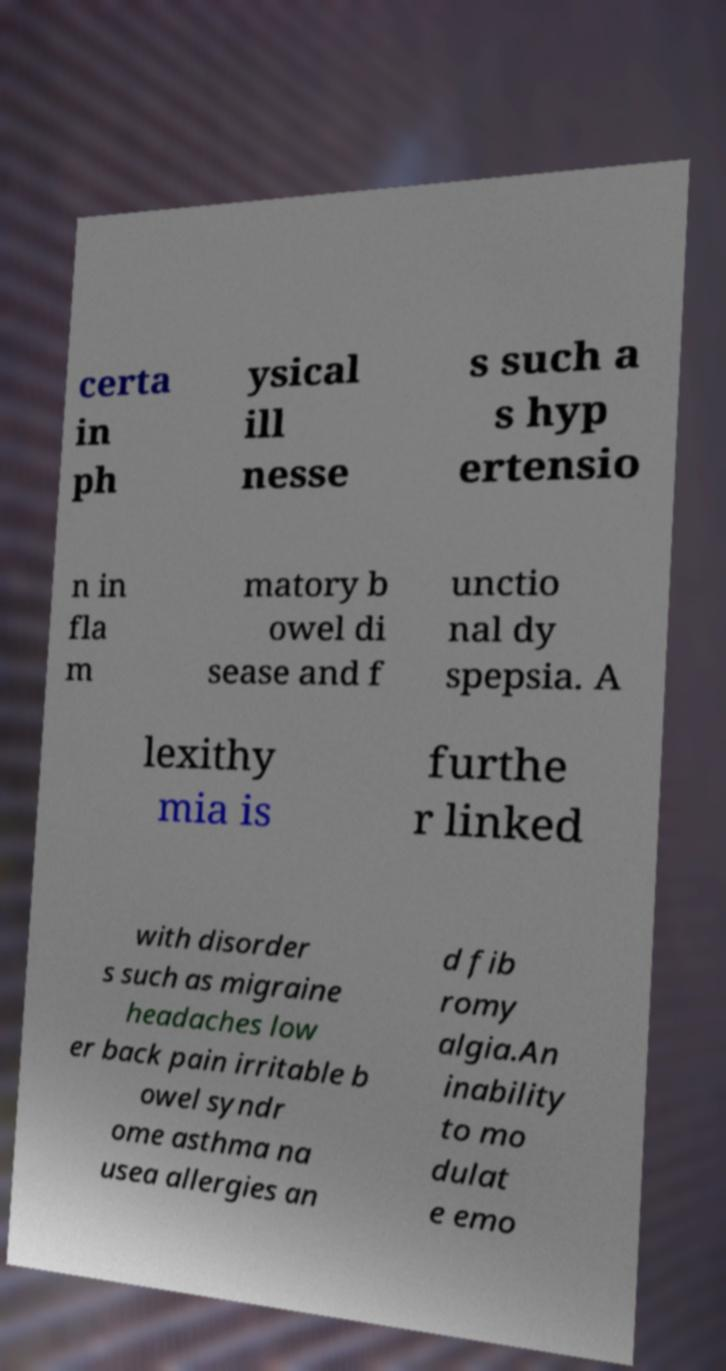I need the written content from this picture converted into text. Can you do that? certa in ph ysical ill nesse s such a s hyp ertensio n in fla m matory b owel di sease and f unctio nal dy spepsia. A lexithy mia is furthe r linked with disorder s such as migraine headaches low er back pain irritable b owel syndr ome asthma na usea allergies an d fib romy algia.An inability to mo dulat e emo 